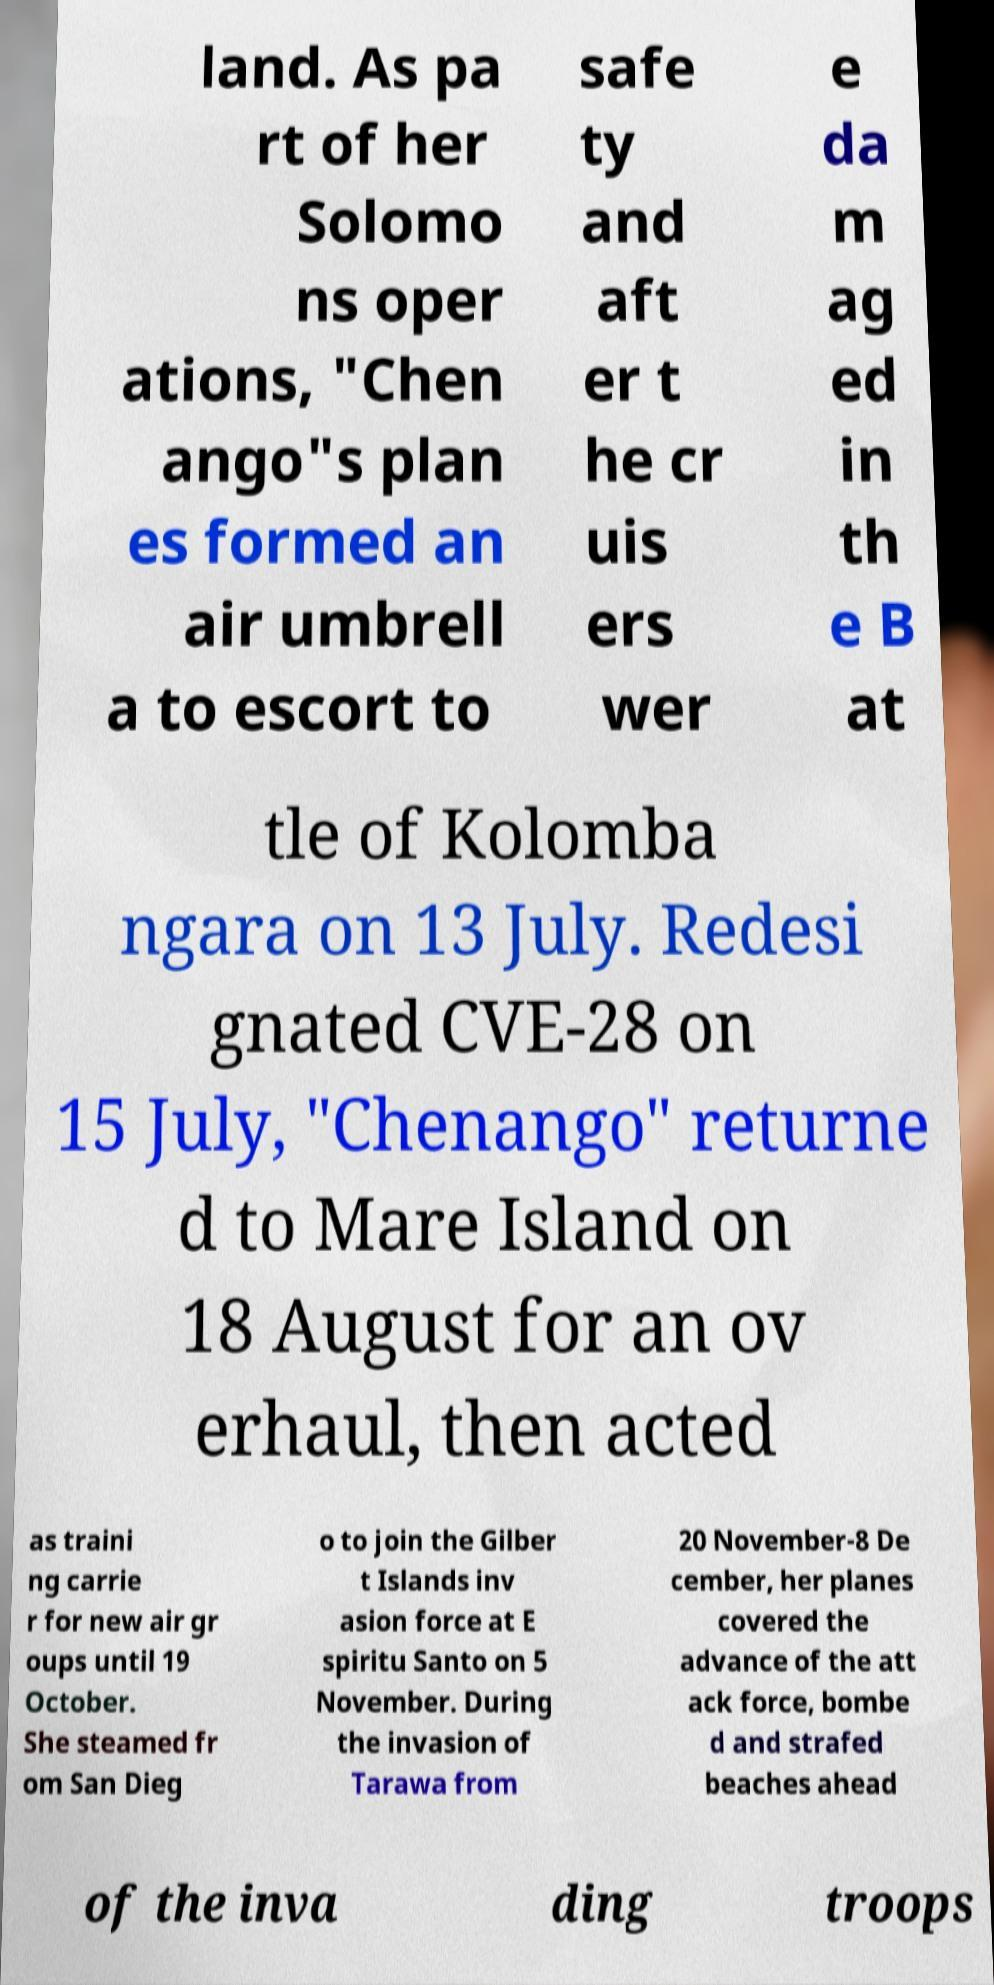I need the written content from this picture converted into text. Can you do that? land. As pa rt of her Solomo ns oper ations, "Chen ango"s plan es formed an air umbrell a to escort to safe ty and aft er t he cr uis ers wer e da m ag ed in th e B at tle of Kolomba ngara on 13 July. Redesi gnated CVE-28 on 15 July, "Chenango" returne d to Mare Island on 18 August for an ov erhaul, then acted as traini ng carrie r for new air gr oups until 19 October. She steamed fr om San Dieg o to join the Gilber t Islands inv asion force at E spiritu Santo on 5 November. During the invasion of Tarawa from 20 November-8 De cember, her planes covered the advance of the att ack force, bombe d and strafed beaches ahead of the inva ding troops 